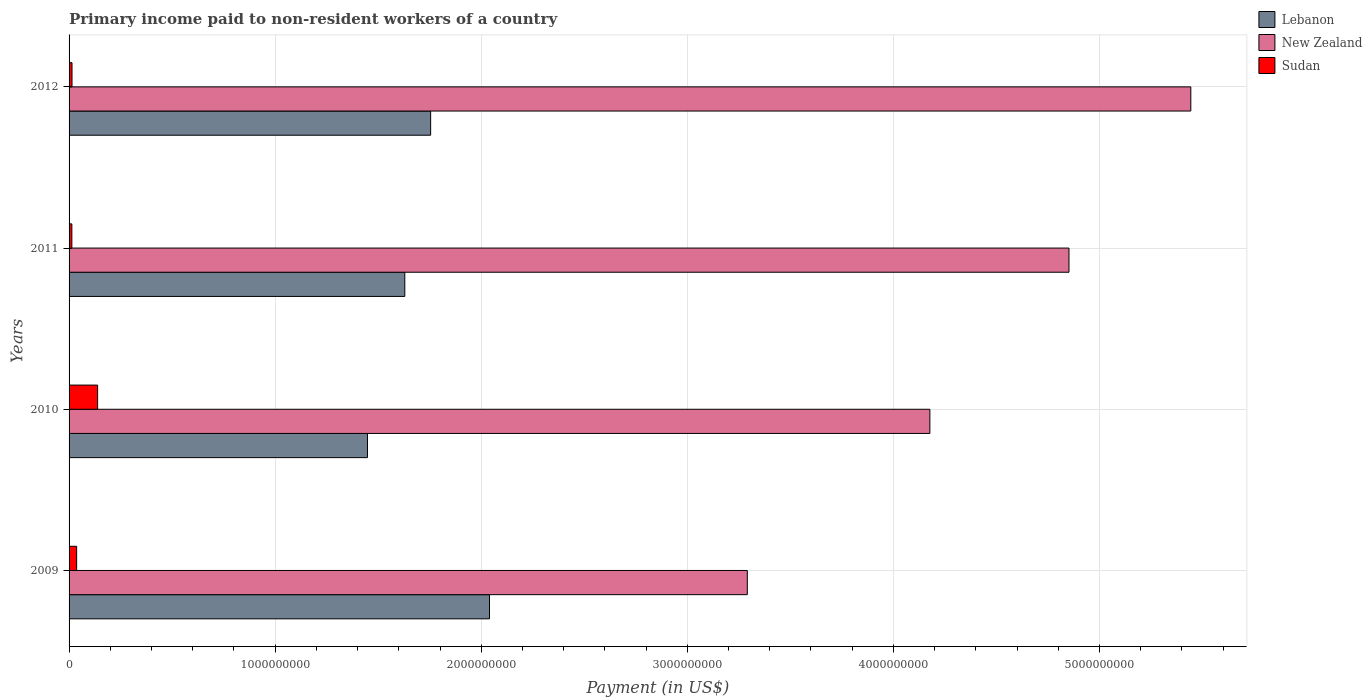How many different coloured bars are there?
Offer a terse response. 3. Are the number of bars per tick equal to the number of legend labels?
Your answer should be compact. Yes. Are the number of bars on each tick of the Y-axis equal?
Provide a succinct answer. Yes. How many bars are there on the 2nd tick from the bottom?
Offer a terse response. 3. What is the label of the 4th group of bars from the top?
Ensure brevity in your answer.  2009. In how many cases, is the number of bars for a given year not equal to the number of legend labels?
Offer a terse response. 0. What is the amount paid to workers in Lebanon in 2009?
Offer a terse response. 2.04e+09. Across all years, what is the maximum amount paid to workers in New Zealand?
Offer a terse response. 5.44e+09. Across all years, what is the minimum amount paid to workers in New Zealand?
Give a very brief answer. 3.29e+09. In which year was the amount paid to workers in Lebanon minimum?
Your response must be concise. 2010. What is the total amount paid to workers in Lebanon in the graph?
Your response must be concise. 6.87e+09. What is the difference between the amount paid to workers in Lebanon in 2010 and that in 2012?
Offer a very short reply. -3.07e+08. What is the difference between the amount paid to workers in Sudan in 2010 and the amount paid to workers in Lebanon in 2011?
Make the answer very short. -1.49e+09. What is the average amount paid to workers in Sudan per year?
Offer a very short reply. 5.08e+07. In the year 2010, what is the difference between the amount paid to workers in Lebanon and amount paid to workers in Sudan?
Ensure brevity in your answer.  1.31e+09. What is the ratio of the amount paid to workers in New Zealand in 2009 to that in 2012?
Provide a short and direct response. 0.6. Is the difference between the amount paid to workers in Lebanon in 2009 and 2012 greater than the difference between the amount paid to workers in Sudan in 2009 and 2012?
Offer a very short reply. Yes. What is the difference between the highest and the second highest amount paid to workers in Sudan?
Provide a succinct answer. 1.02e+08. What is the difference between the highest and the lowest amount paid to workers in Lebanon?
Provide a short and direct response. 5.92e+08. In how many years, is the amount paid to workers in New Zealand greater than the average amount paid to workers in New Zealand taken over all years?
Provide a short and direct response. 2. What does the 2nd bar from the top in 2011 represents?
Offer a terse response. New Zealand. What does the 3rd bar from the bottom in 2011 represents?
Ensure brevity in your answer.  Sudan. How many bars are there?
Make the answer very short. 12. Are all the bars in the graph horizontal?
Provide a succinct answer. Yes. Are the values on the major ticks of X-axis written in scientific E-notation?
Keep it short and to the point. No. Does the graph contain any zero values?
Your answer should be very brief. No. Does the graph contain grids?
Keep it short and to the point. Yes. Where does the legend appear in the graph?
Offer a very short reply. Top right. How many legend labels are there?
Offer a terse response. 3. What is the title of the graph?
Ensure brevity in your answer.  Primary income paid to non-resident workers of a country. Does "Kazakhstan" appear as one of the legend labels in the graph?
Offer a terse response. No. What is the label or title of the X-axis?
Provide a succinct answer. Payment (in US$). What is the label or title of the Y-axis?
Make the answer very short. Years. What is the Payment (in US$) of Lebanon in 2009?
Your response must be concise. 2.04e+09. What is the Payment (in US$) of New Zealand in 2009?
Make the answer very short. 3.29e+09. What is the Payment (in US$) in Sudan in 2009?
Ensure brevity in your answer.  3.67e+07. What is the Payment (in US$) of Lebanon in 2010?
Keep it short and to the point. 1.45e+09. What is the Payment (in US$) in New Zealand in 2010?
Give a very brief answer. 4.18e+09. What is the Payment (in US$) of Sudan in 2010?
Your answer should be compact. 1.39e+08. What is the Payment (in US$) of Lebanon in 2011?
Offer a terse response. 1.63e+09. What is the Payment (in US$) in New Zealand in 2011?
Offer a very short reply. 4.85e+09. What is the Payment (in US$) of Sudan in 2011?
Make the answer very short. 1.35e+07. What is the Payment (in US$) in Lebanon in 2012?
Give a very brief answer. 1.75e+09. What is the Payment (in US$) in New Zealand in 2012?
Offer a very short reply. 5.44e+09. What is the Payment (in US$) in Sudan in 2012?
Provide a succinct answer. 1.43e+07. Across all years, what is the maximum Payment (in US$) of Lebanon?
Offer a very short reply. 2.04e+09. Across all years, what is the maximum Payment (in US$) in New Zealand?
Ensure brevity in your answer.  5.44e+09. Across all years, what is the maximum Payment (in US$) in Sudan?
Make the answer very short. 1.39e+08. Across all years, what is the minimum Payment (in US$) in Lebanon?
Make the answer very short. 1.45e+09. Across all years, what is the minimum Payment (in US$) of New Zealand?
Offer a very short reply. 3.29e+09. Across all years, what is the minimum Payment (in US$) of Sudan?
Your answer should be compact. 1.35e+07. What is the total Payment (in US$) of Lebanon in the graph?
Ensure brevity in your answer.  6.87e+09. What is the total Payment (in US$) in New Zealand in the graph?
Give a very brief answer. 1.78e+1. What is the total Payment (in US$) in Sudan in the graph?
Your response must be concise. 2.03e+08. What is the difference between the Payment (in US$) in Lebanon in 2009 and that in 2010?
Offer a very short reply. 5.92e+08. What is the difference between the Payment (in US$) in New Zealand in 2009 and that in 2010?
Your response must be concise. -8.86e+08. What is the difference between the Payment (in US$) in Sudan in 2009 and that in 2010?
Provide a short and direct response. -1.02e+08. What is the difference between the Payment (in US$) of Lebanon in 2009 and that in 2011?
Give a very brief answer. 4.11e+08. What is the difference between the Payment (in US$) of New Zealand in 2009 and that in 2011?
Your answer should be very brief. -1.56e+09. What is the difference between the Payment (in US$) of Sudan in 2009 and that in 2011?
Make the answer very short. 2.32e+07. What is the difference between the Payment (in US$) in Lebanon in 2009 and that in 2012?
Offer a terse response. 2.86e+08. What is the difference between the Payment (in US$) in New Zealand in 2009 and that in 2012?
Your answer should be very brief. -2.15e+09. What is the difference between the Payment (in US$) in Sudan in 2009 and that in 2012?
Your response must be concise. 2.25e+07. What is the difference between the Payment (in US$) of Lebanon in 2010 and that in 2011?
Provide a short and direct response. -1.81e+08. What is the difference between the Payment (in US$) of New Zealand in 2010 and that in 2011?
Ensure brevity in your answer.  -6.75e+08. What is the difference between the Payment (in US$) of Sudan in 2010 and that in 2011?
Keep it short and to the point. 1.25e+08. What is the difference between the Payment (in US$) in Lebanon in 2010 and that in 2012?
Offer a very short reply. -3.07e+08. What is the difference between the Payment (in US$) in New Zealand in 2010 and that in 2012?
Your answer should be compact. -1.27e+09. What is the difference between the Payment (in US$) of Sudan in 2010 and that in 2012?
Offer a terse response. 1.24e+08. What is the difference between the Payment (in US$) of Lebanon in 2011 and that in 2012?
Your response must be concise. -1.25e+08. What is the difference between the Payment (in US$) in New Zealand in 2011 and that in 2012?
Keep it short and to the point. -5.91e+08. What is the difference between the Payment (in US$) of Sudan in 2011 and that in 2012?
Provide a short and direct response. -7.31e+05. What is the difference between the Payment (in US$) in Lebanon in 2009 and the Payment (in US$) in New Zealand in 2010?
Ensure brevity in your answer.  -2.14e+09. What is the difference between the Payment (in US$) in Lebanon in 2009 and the Payment (in US$) in Sudan in 2010?
Offer a terse response. 1.90e+09. What is the difference between the Payment (in US$) in New Zealand in 2009 and the Payment (in US$) in Sudan in 2010?
Your response must be concise. 3.15e+09. What is the difference between the Payment (in US$) in Lebanon in 2009 and the Payment (in US$) in New Zealand in 2011?
Provide a succinct answer. -2.81e+09. What is the difference between the Payment (in US$) of Lebanon in 2009 and the Payment (in US$) of Sudan in 2011?
Offer a terse response. 2.03e+09. What is the difference between the Payment (in US$) in New Zealand in 2009 and the Payment (in US$) in Sudan in 2011?
Make the answer very short. 3.28e+09. What is the difference between the Payment (in US$) of Lebanon in 2009 and the Payment (in US$) of New Zealand in 2012?
Give a very brief answer. -3.40e+09. What is the difference between the Payment (in US$) in Lebanon in 2009 and the Payment (in US$) in Sudan in 2012?
Provide a short and direct response. 2.03e+09. What is the difference between the Payment (in US$) in New Zealand in 2009 and the Payment (in US$) in Sudan in 2012?
Offer a very short reply. 3.28e+09. What is the difference between the Payment (in US$) in Lebanon in 2010 and the Payment (in US$) in New Zealand in 2011?
Provide a short and direct response. -3.40e+09. What is the difference between the Payment (in US$) in Lebanon in 2010 and the Payment (in US$) in Sudan in 2011?
Ensure brevity in your answer.  1.43e+09. What is the difference between the Payment (in US$) in New Zealand in 2010 and the Payment (in US$) in Sudan in 2011?
Your answer should be very brief. 4.16e+09. What is the difference between the Payment (in US$) in Lebanon in 2010 and the Payment (in US$) in New Zealand in 2012?
Provide a succinct answer. -4.00e+09. What is the difference between the Payment (in US$) of Lebanon in 2010 and the Payment (in US$) of Sudan in 2012?
Offer a very short reply. 1.43e+09. What is the difference between the Payment (in US$) in New Zealand in 2010 and the Payment (in US$) in Sudan in 2012?
Your response must be concise. 4.16e+09. What is the difference between the Payment (in US$) of Lebanon in 2011 and the Payment (in US$) of New Zealand in 2012?
Provide a short and direct response. -3.81e+09. What is the difference between the Payment (in US$) in Lebanon in 2011 and the Payment (in US$) in Sudan in 2012?
Provide a succinct answer. 1.61e+09. What is the difference between the Payment (in US$) in New Zealand in 2011 and the Payment (in US$) in Sudan in 2012?
Offer a very short reply. 4.84e+09. What is the average Payment (in US$) of Lebanon per year?
Your response must be concise. 1.72e+09. What is the average Payment (in US$) in New Zealand per year?
Your answer should be compact. 4.44e+09. What is the average Payment (in US$) in Sudan per year?
Provide a succinct answer. 5.08e+07. In the year 2009, what is the difference between the Payment (in US$) of Lebanon and Payment (in US$) of New Zealand?
Your response must be concise. -1.25e+09. In the year 2009, what is the difference between the Payment (in US$) of Lebanon and Payment (in US$) of Sudan?
Provide a short and direct response. 2.00e+09. In the year 2009, what is the difference between the Payment (in US$) of New Zealand and Payment (in US$) of Sudan?
Provide a succinct answer. 3.25e+09. In the year 2010, what is the difference between the Payment (in US$) in Lebanon and Payment (in US$) in New Zealand?
Your response must be concise. -2.73e+09. In the year 2010, what is the difference between the Payment (in US$) of Lebanon and Payment (in US$) of Sudan?
Ensure brevity in your answer.  1.31e+09. In the year 2010, what is the difference between the Payment (in US$) of New Zealand and Payment (in US$) of Sudan?
Ensure brevity in your answer.  4.04e+09. In the year 2011, what is the difference between the Payment (in US$) in Lebanon and Payment (in US$) in New Zealand?
Offer a very short reply. -3.22e+09. In the year 2011, what is the difference between the Payment (in US$) of Lebanon and Payment (in US$) of Sudan?
Your answer should be compact. 1.62e+09. In the year 2011, what is the difference between the Payment (in US$) of New Zealand and Payment (in US$) of Sudan?
Offer a terse response. 4.84e+09. In the year 2012, what is the difference between the Payment (in US$) in Lebanon and Payment (in US$) in New Zealand?
Your answer should be very brief. -3.69e+09. In the year 2012, what is the difference between the Payment (in US$) in Lebanon and Payment (in US$) in Sudan?
Provide a short and direct response. 1.74e+09. In the year 2012, what is the difference between the Payment (in US$) of New Zealand and Payment (in US$) of Sudan?
Your answer should be compact. 5.43e+09. What is the ratio of the Payment (in US$) of Lebanon in 2009 to that in 2010?
Offer a terse response. 1.41. What is the ratio of the Payment (in US$) in New Zealand in 2009 to that in 2010?
Your answer should be compact. 0.79. What is the ratio of the Payment (in US$) of Sudan in 2009 to that in 2010?
Offer a terse response. 0.27. What is the ratio of the Payment (in US$) of Lebanon in 2009 to that in 2011?
Offer a terse response. 1.25. What is the ratio of the Payment (in US$) of New Zealand in 2009 to that in 2011?
Offer a very short reply. 0.68. What is the ratio of the Payment (in US$) of Sudan in 2009 to that in 2011?
Your answer should be very brief. 2.71. What is the ratio of the Payment (in US$) in Lebanon in 2009 to that in 2012?
Your response must be concise. 1.16. What is the ratio of the Payment (in US$) of New Zealand in 2009 to that in 2012?
Make the answer very short. 0.6. What is the ratio of the Payment (in US$) in Sudan in 2009 to that in 2012?
Ensure brevity in your answer.  2.57. What is the ratio of the Payment (in US$) of New Zealand in 2010 to that in 2011?
Provide a succinct answer. 0.86. What is the ratio of the Payment (in US$) in Sudan in 2010 to that in 2011?
Give a very brief answer. 10.23. What is the ratio of the Payment (in US$) of Lebanon in 2010 to that in 2012?
Offer a very short reply. 0.83. What is the ratio of the Payment (in US$) in New Zealand in 2010 to that in 2012?
Your answer should be very brief. 0.77. What is the ratio of the Payment (in US$) in Sudan in 2010 to that in 2012?
Give a very brief answer. 9.71. What is the ratio of the Payment (in US$) of Lebanon in 2011 to that in 2012?
Give a very brief answer. 0.93. What is the ratio of the Payment (in US$) in New Zealand in 2011 to that in 2012?
Provide a short and direct response. 0.89. What is the ratio of the Payment (in US$) in Sudan in 2011 to that in 2012?
Provide a short and direct response. 0.95. What is the difference between the highest and the second highest Payment (in US$) in Lebanon?
Provide a short and direct response. 2.86e+08. What is the difference between the highest and the second highest Payment (in US$) in New Zealand?
Keep it short and to the point. 5.91e+08. What is the difference between the highest and the second highest Payment (in US$) of Sudan?
Offer a very short reply. 1.02e+08. What is the difference between the highest and the lowest Payment (in US$) of Lebanon?
Offer a terse response. 5.92e+08. What is the difference between the highest and the lowest Payment (in US$) of New Zealand?
Keep it short and to the point. 2.15e+09. What is the difference between the highest and the lowest Payment (in US$) in Sudan?
Your answer should be compact. 1.25e+08. 